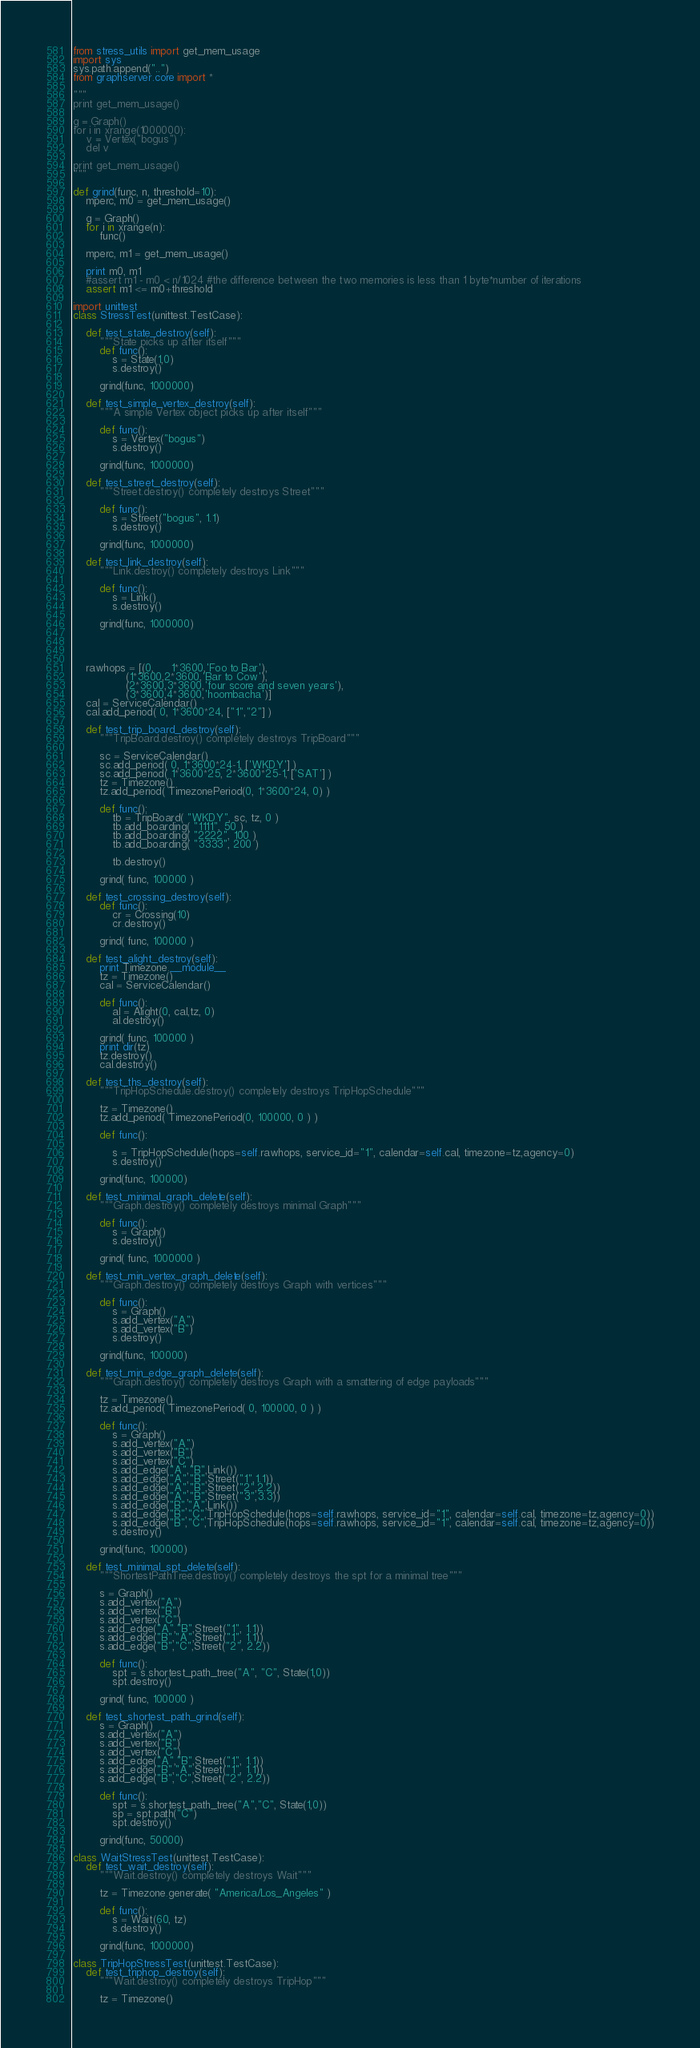Convert code to text. <code><loc_0><loc_0><loc_500><loc_500><_Python_>from stress_utils import get_mem_usage
import sys
sys.path.append("..")
from graphserver.core import *

"""
print get_mem_usage()

g = Graph()
for i in xrange(1000000):
    v = Vertex("bogus")
    del v
    
print get_mem_usage()
"""

def grind(func, n, threshold=10):
    mperc, m0 = get_mem_usage()

    g = Graph()
    for i in xrange(n):
        func()
        
    mperc, m1 = get_mem_usage()
    
    print m0, m1
    #assert m1 - m0 < n/1024 #the difference between the two memories is less than 1 byte*number of iterations
    assert m1 <= m0+threshold

import unittest
class StressTest(unittest.TestCase):

    def test_state_destroy(self):
        """State picks up after itself"""
        def func():
            s = State(1,0)
            s.destroy()
            
        grind(func, 1000000)
        
    def test_simple_vertex_destroy(self):
        """A simple Vertex object picks up after itself"""
        
        def func():
            s = Vertex("bogus")
            s.destroy()
            
        grind(func, 1000000)
        
    def test_street_destroy(self):
        """Street.destroy() completely destroys Street"""
        
        def func():
            s = Street("bogus", 1.1)
            s.destroy()
            
        grind(func, 1000000)
        
    def test_link_destroy(self):
        """Link.destroy() completely destroys Link"""
        
        def func():
            s = Link()
            s.destroy()
            
        grind(func, 1000000)
        

        

    rawhops = [(0,     1*3600,'Foo to Bar'),
                (1*3600,2*3600,'Bar to Cow'),
                (2*3600,3*3600,'four score and seven years'),
                (3*3600,4*3600,'hoombacha')]
    cal = ServiceCalendar()
    cal.add_period( 0, 1*3600*24, ["1","2"] )

    def test_trip_board_destroy(self):
        """TripBoard.destroy() completely destroys TripBoard"""
        
        sc = ServiceCalendar()
        sc.add_period( 0, 1*3600*24-1, ['WKDY'] )
        sc.add_period( 1*3600*25, 2*3600*25-1, ['SAT'] )
        tz = Timezone()
        tz.add_period( TimezonePeriod(0, 1*3600*24, 0) )
        
        def func():
            tb = TripBoard( "WKDY", sc, tz, 0 )
            tb.add_boarding( "1111", 50 )
            tb.add_boarding( "2222", 100 )
            tb.add_boarding( "3333", 200 )
            
            tb.destroy()
            
        grind( func, 100000 )
        
    def test_crossing_destroy(self):
        def func():
            cr = Crossing(10)
            cr.destroy()
            
        grind( func, 100000 )
        
    def test_alight_destroy(self):
        print Timezone.__module__
        tz = Timezone()                    
        cal = ServiceCalendar()            
                                       
        def func():                        
            al = Alight(0, cal,tz, 0)      
            al.destroy()                   
                                       
        grind( func, 100000 )           
        print dir(tz)                      
        tz.destroy()                    
        cal.destroy()                   

    def test_ths_destroy(self):
        """TripHopSchedule.destroy() completely destroys TripHopSchedule"""
        
        tz = Timezone()
        tz.add_period( TimezonePeriod(0, 100000, 0 ) )
        
        def func():

            s = TripHopSchedule(hops=self.rawhops, service_id="1", calendar=self.cal, timezone=tz,agency=0)
            s.destroy()
            
        grind(func, 100000)
        
    def test_minimal_graph_delete(self):
        """Graph.destroy() completely destroys minimal Graph"""
        
        def func():
            s = Graph()
            s.destroy()
            
        grind( func, 1000000 )
        
    def test_min_vertex_graph_delete(self):
        """Graph.destroy() completely destroys Graph with vertices"""
        
        def func():
            s = Graph()
            s.add_vertex("A")
            s.add_vertex("B")
            s.destroy()
            
        grind(func, 100000)
        
    def test_min_edge_graph_delete(self):
        """Graph.destroy() completely destroys Graph with a smattering of edge payloads"""
        
        tz = Timezone()
        tz.add_period( TimezonePeriod( 0, 100000, 0 ) )
        
        def func():
            s = Graph()
            s.add_vertex("A")
            s.add_vertex("B")
            s.add_vertex("C")
            s.add_edge("A","B",Link())
            s.add_edge("A","B",Street("1",1.1))
            s.add_edge("A","B",Street("2",2.2))
            s.add_edge("A","B",Street("3",3.3))
            s.add_edge("B","A",Link())
            s.add_edge("B","C",TripHopSchedule(hops=self.rawhops, service_id="1", calendar=self.cal, timezone=tz,agency=0))
            s.add_edge("B","C",TripHopSchedule(hops=self.rawhops, service_id="1", calendar=self.cal, timezone=tz,agency=0))
            s.destroy()
            
        grind(func, 100000)
        
    def test_minimal_spt_delete(self):
        """ShortestPathTree.destroy() completely destroys the spt for a minimal tree"""
        
        s = Graph()
        s.add_vertex("A")
        s.add_vertex("B")
        s.add_vertex("C")
        s.add_edge("A","B",Street("1", 1.1))
        s.add_edge("B","A",Street("1", 1.1))
        s.add_edge("B","C",Street("2", 2.2))
        
        def func():
            spt = s.shortest_path_tree("A", "C", State(1,0))
            spt.destroy()
            
        grind( func, 100000 )
        
    def test_shortest_path_grind(self):
        s = Graph()
        s.add_vertex("A")
        s.add_vertex("B")
        s.add_vertex("C")
        s.add_edge("A","B",Street("1", 1.1))
        s.add_edge("B","A",Street("1", 1.1))
        s.add_edge("B","C",Street("2", 2.2))
        
        def func():
            spt = s.shortest_path_tree("A","C", State(1,0))
            sp = spt.path("C")
            spt.destroy()
            
        grind(func, 50000)

class WaitStressTest(unittest.TestCase):
    def test_wait_destroy(self):
        """Wait.destroy() completely destroys Wait"""
        
        tz = Timezone.generate( "America/Los_Angeles" )
        
        def func():
            s = Wait(60, tz)
            s.destroy()
            
        grind(func, 1000000)
        
class TripHopStressTest(unittest.TestCase):
    def test_triphop_destroy(self):
        """Wait.destroy() completely destroys TripHop"""
        
        tz = Timezone()</code> 